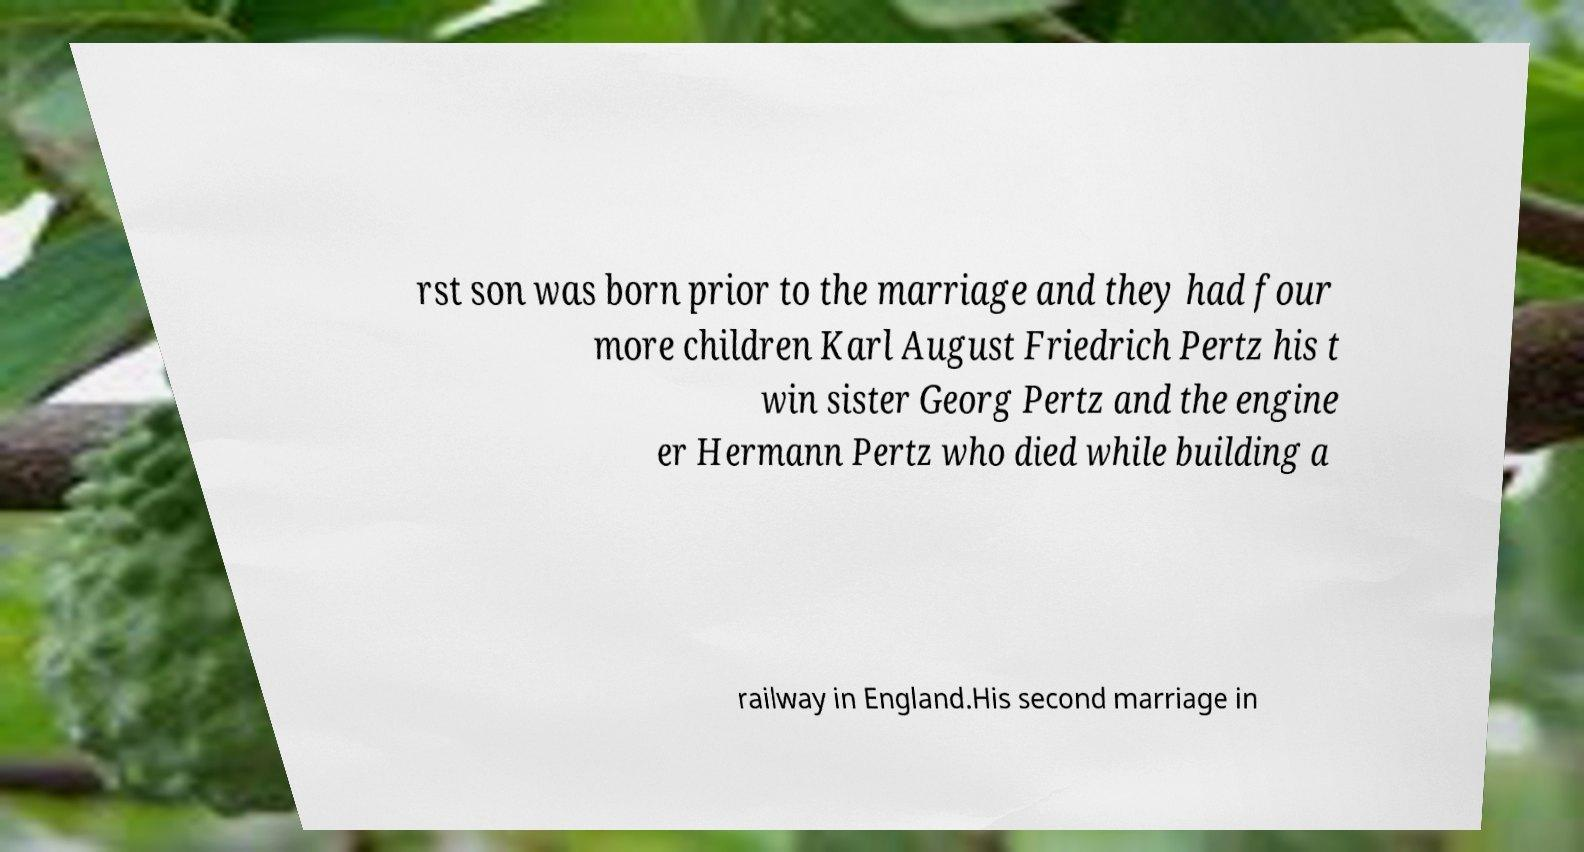Please read and relay the text visible in this image. What does it say? rst son was born prior to the marriage and they had four more children Karl August Friedrich Pertz his t win sister Georg Pertz and the engine er Hermann Pertz who died while building a railway in England.His second marriage in 